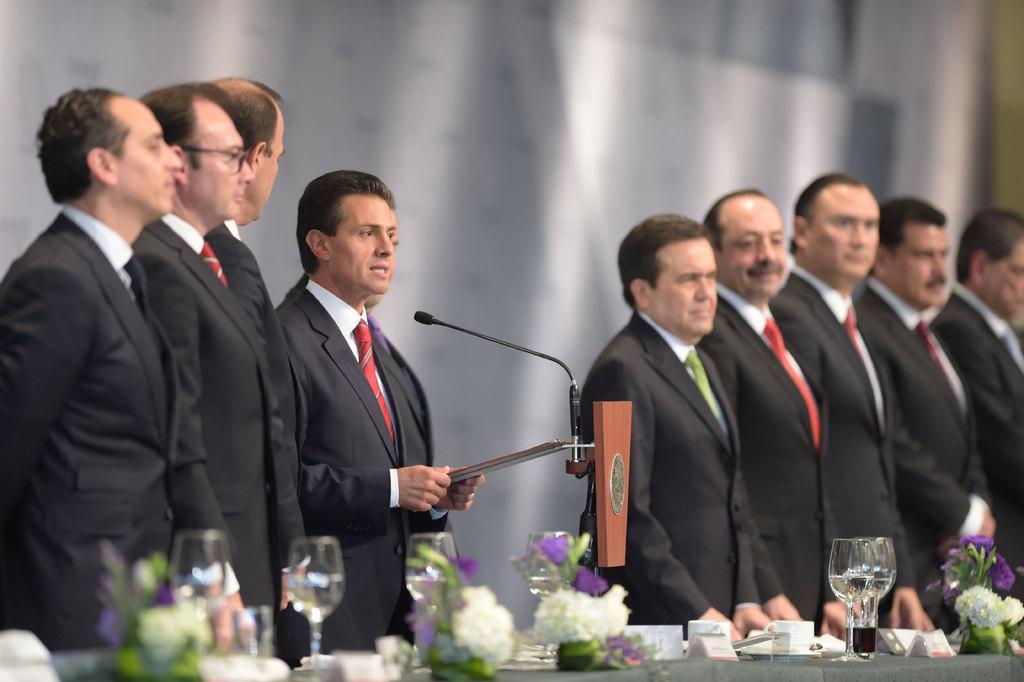Could you give a brief overview of what you see in this image? It is a conference. Group of men are standing in front of the table in a row and the middle person is speaking something through the mic,all of them are wearing blazer and on the table there are many glasses and flowers and some papers. 